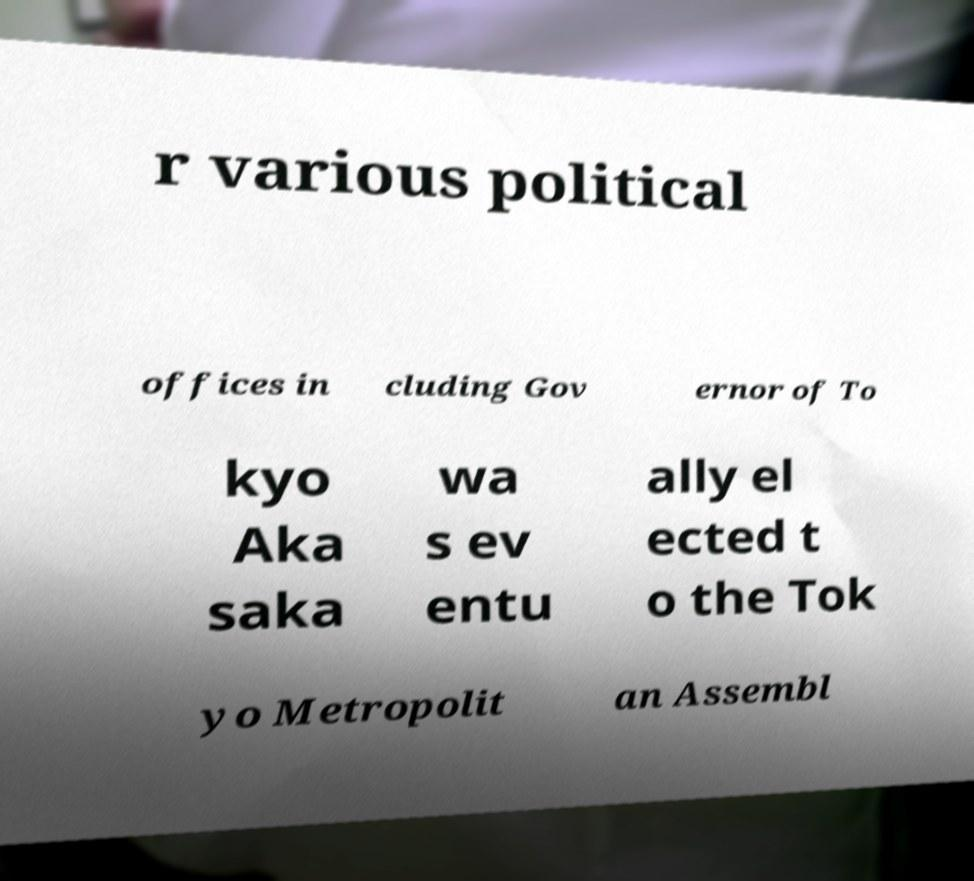For documentation purposes, I need the text within this image transcribed. Could you provide that? r various political offices in cluding Gov ernor of To kyo Aka saka wa s ev entu ally el ected t o the Tok yo Metropolit an Assembl 